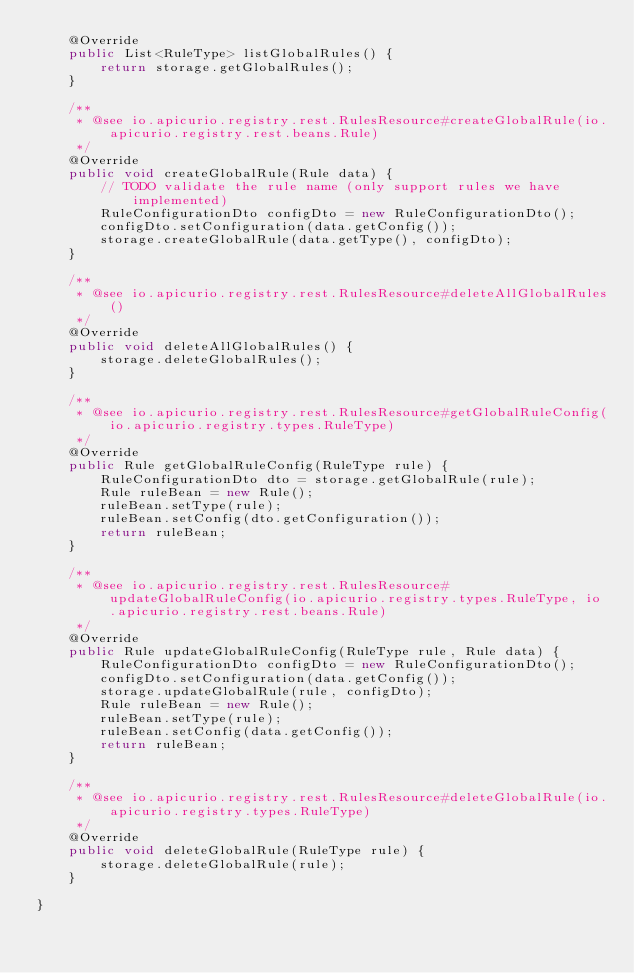Convert code to text. <code><loc_0><loc_0><loc_500><loc_500><_Java_>    @Override
    public List<RuleType> listGlobalRules() {
        return storage.getGlobalRules();
    }

    /**
     * @see io.apicurio.registry.rest.RulesResource#createGlobalRule(io.apicurio.registry.rest.beans.Rule)
     */
    @Override
    public void createGlobalRule(Rule data) {
        // TODO validate the rule name (only support rules we have implemented)
        RuleConfigurationDto configDto = new RuleConfigurationDto();
        configDto.setConfiguration(data.getConfig());
        storage.createGlobalRule(data.getType(), configDto);
    }

    /**
     * @see io.apicurio.registry.rest.RulesResource#deleteAllGlobalRules()
     */
    @Override
    public void deleteAllGlobalRules() {
        storage.deleteGlobalRules();
    }

    /**
     * @see io.apicurio.registry.rest.RulesResource#getGlobalRuleConfig(io.apicurio.registry.types.RuleType)
     */
    @Override
    public Rule getGlobalRuleConfig(RuleType rule) {
        RuleConfigurationDto dto = storage.getGlobalRule(rule);
        Rule ruleBean = new Rule();
        ruleBean.setType(rule);
        ruleBean.setConfig(dto.getConfiguration());
        return ruleBean;
    }

    /**
     * @see io.apicurio.registry.rest.RulesResource#updateGlobalRuleConfig(io.apicurio.registry.types.RuleType, io.apicurio.registry.rest.beans.Rule)
     */
    @Override
    public Rule updateGlobalRuleConfig(RuleType rule, Rule data) {
        RuleConfigurationDto configDto = new RuleConfigurationDto();
        configDto.setConfiguration(data.getConfig());
        storage.updateGlobalRule(rule, configDto);
        Rule ruleBean = new Rule();
        ruleBean.setType(rule);
        ruleBean.setConfig(data.getConfig());
        return ruleBean;
    }

    /**
     * @see io.apicurio.registry.rest.RulesResource#deleteGlobalRule(io.apicurio.registry.types.RuleType)
     */
    @Override
    public void deleteGlobalRule(RuleType rule) {
        storage.deleteGlobalRule(rule);
    }

}
</code> 